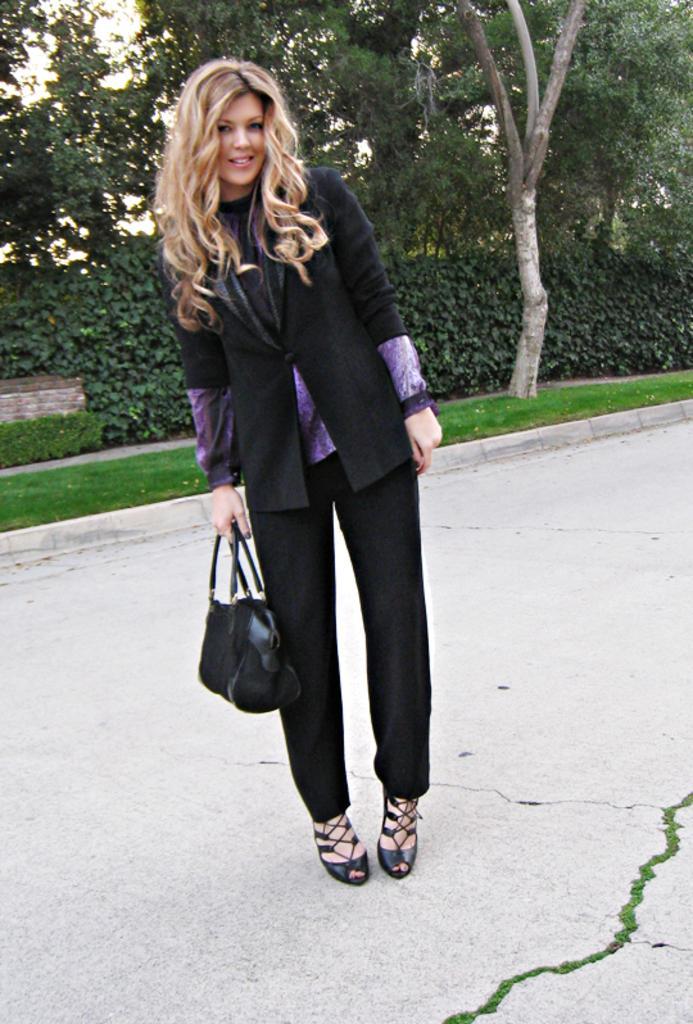Can you describe this image briefly? A woman is standing and holding hand bag in her hand. In the background there are trees and grass. 